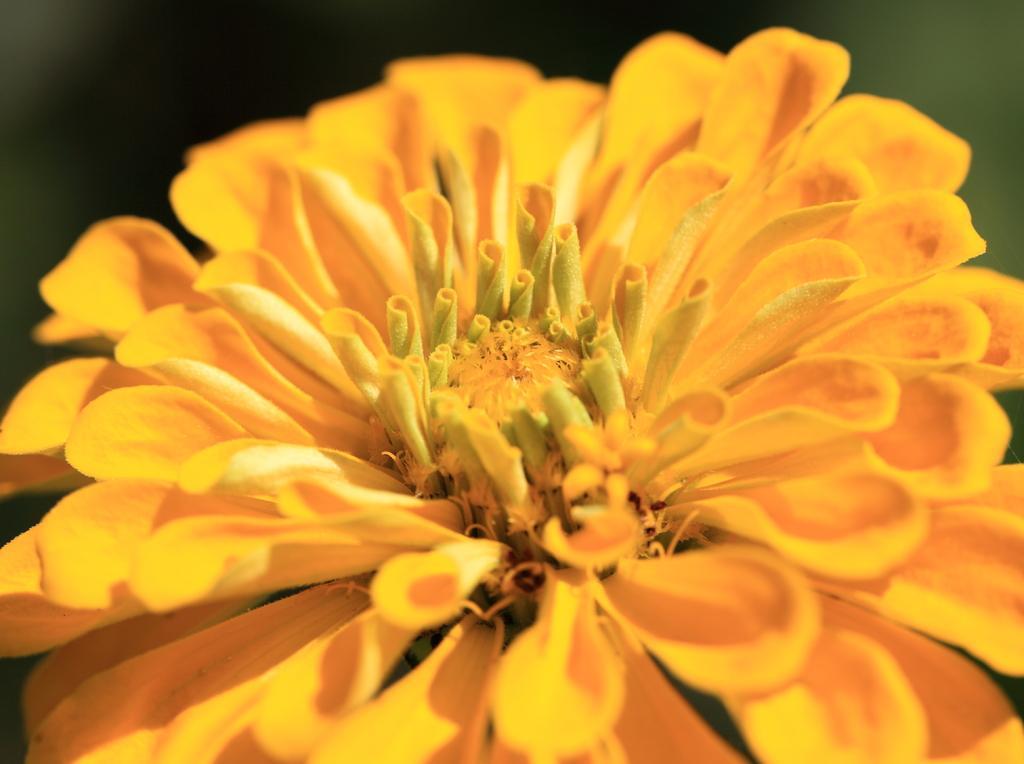In one or two sentences, can you explain what this image depicts? In this image there is a yellow flower. 